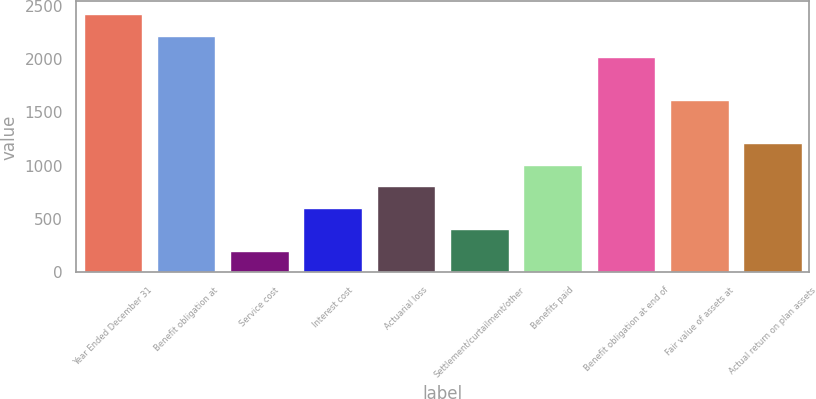Convert chart. <chart><loc_0><loc_0><loc_500><loc_500><bar_chart><fcel>Year Ended December 31<fcel>Benefit obligation at<fcel>Service cost<fcel>Interest cost<fcel>Actuarial loss<fcel>Settlement/curtailment/other<fcel>Benefits paid<fcel>Benefit obligation at end of<fcel>Fair value of assets at<fcel>Actual return on plan assets<nl><fcel>2419.8<fcel>2218.4<fcel>204.4<fcel>607.2<fcel>808.6<fcel>405.8<fcel>1010<fcel>2017<fcel>1614.2<fcel>1211.4<nl></chart> 